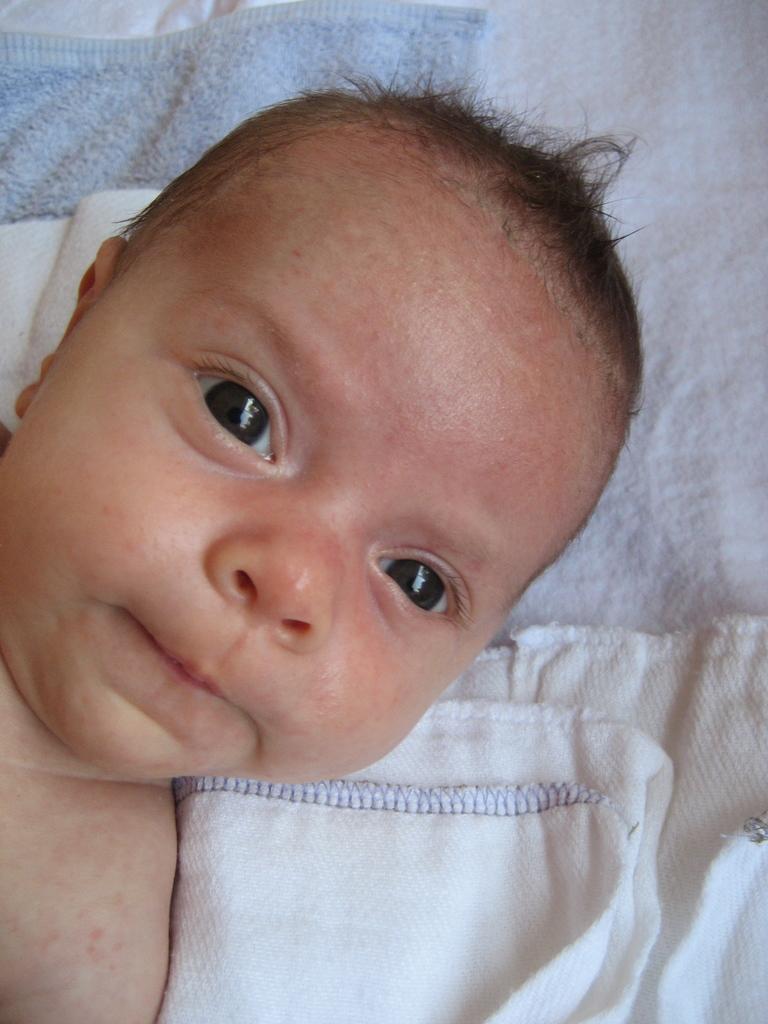Describe this image in one or two sentences. In this picture we can observe a baby. There is a blue color towel and white color napkin here. 